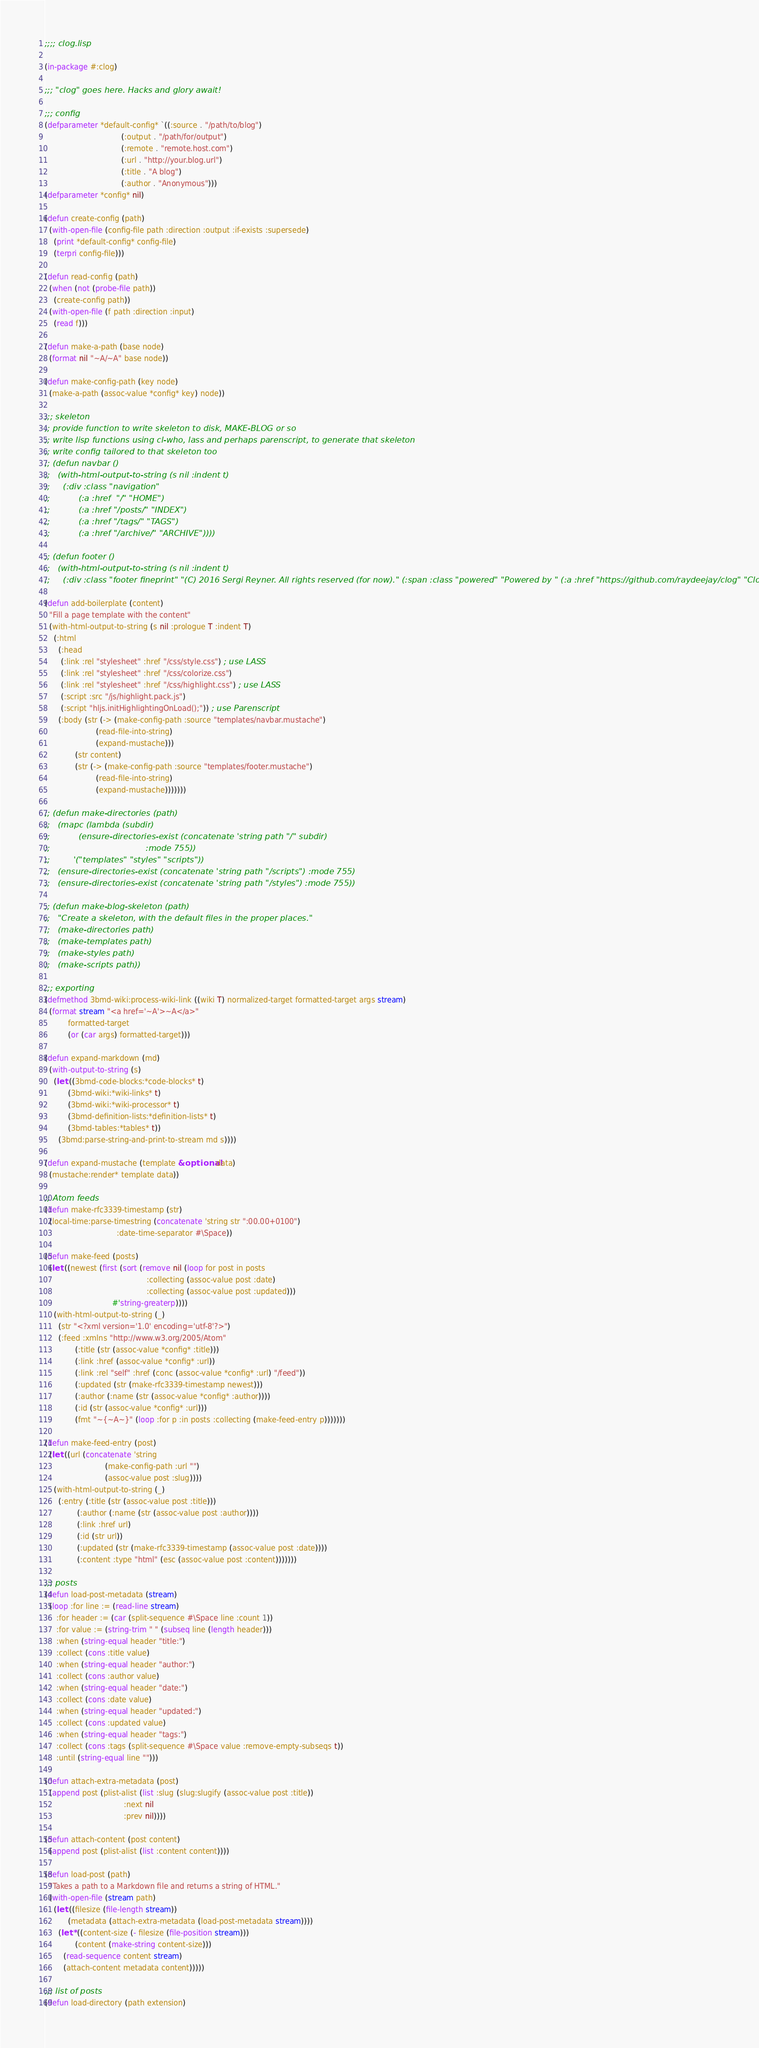Convert code to text. <code><loc_0><loc_0><loc_500><loc_500><_Lisp_>;;;; clog.lisp

(in-package #:clog)

;;; "clog" goes here. Hacks and glory await!

;;; config
(defparameter *default-config* `((:source . "/path/to/blog")
                                 (:output . "/path/for/output")
                                 (:remote . "remote.host.com")
                                 (:url . "http://your.blog.url")
                                 (:title . "A blog")
                                 (:author . "Anonymous")))
(defparameter *config* nil)

(defun create-config (path)
  (with-open-file (config-file path :direction :output :if-exists :supersede)
    (print *default-config* config-file)
    (terpri config-file)))

(defun read-config (path)
  (when (not (probe-file path))
    (create-config path))
  (with-open-file (f path :direction :input)
    (read f)))

(defun make-a-path (base node)
  (format nil "~A/~A" base node))

(defun make-config-path (key node)
  (make-a-path (assoc-value *config* key) node))

;;; skeleton
;; provide function to write skeleton to disk, MAKE-BLOG or so
;; write lisp functions using cl-who, lass and perhaps parenscript, to generate that skeleton
;; write config tailored to that skeleton too
;; (defun navbar ()
;;   (with-html-output-to-string (s nil :indent t)
;;     (:div :class "navigation"
;;           (:a :href  "/" "HOME")
;;           (:a :href "/posts/" "INDEX")
;;           (:a :href "/tags/" "TAGS")
;;           (:a :href "/archive/" "ARCHIVE"))))

;; (defun footer ()
;;   (with-html-output-to-string (s nil :indent t)
;;     (:div :class "footer fineprint" "(C) 2016 Sergi Reyner. All rights reserved (for now)." (:span :class "powered" "Powered by " (:a :href "https://github.com/raydeejay/clog" "Clog") "."))))

(defun add-boilerplate (content)
  "Fill a page template with the content"
  (with-html-output-to-string (s nil :prologue T :indent T)
    (:html
      (:head
       (:link :rel "stylesheet" :href "/css/style.css") ; use LASS
       (:link :rel "stylesheet" :href "/css/colorize.css")
       (:link :rel "stylesheet" :href "/css/highlight.css") ; use LASS
       (:script :src "/js/highlight.pack.js")
       (:script "hljs.initHighlightingOnLoad();")) ; use Parenscript
      (:body (str (-> (make-config-path :source "templates/navbar.mustache")
                      (read-file-into-string)
                      (expand-mustache)))
             (str content)
             (str (-> (make-config-path :source "templates/footer.mustache")
                      (read-file-into-string)
                      (expand-mustache)))))))

;; (defun make-directories (path)
;;   (mapc (lambda (subdir)
;;           (ensure-directories-exist (concatenate 'string path "/" subdir)
;;                                     :mode 755))
;;         '("templates" "styles" "scripts"))
;;   (ensure-directories-exist (concatenate 'string path "/scripts") :mode 755)
;;   (ensure-directories-exist (concatenate 'string path "/styles") :mode 755))

;; (defun make-blog-skeleton (path)
;;   "Create a skeleton, with the default files in the proper places."
;;   (make-directories path)
;;   (make-templates path)
;;   (make-styles path)
;;   (make-scripts path))

;;; exporting
(defmethod 3bmd-wiki:process-wiki-link ((wiki T) normalized-target formatted-target args stream)
  (format stream "<a href='~A'>~A</a>"
          formatted-target
          (or (car args) formatted-target)))

(defun expand-markdown (md)
  (with-output-to-string (s)
    (let ((3bmd-code-blocks:*code-blocks* t)
          (3bmd-wiki:*wiki-links* t)
          (3bmd-wiki:*wiki-processor* t)
          (3bmd-definition-lists:*definition-lists* t)
          (3bmd-tables:*tables* t))
      (3bmd:parse-string-and-print-to-stream md s))))

(defun expand-mustache (template &optional data)
  (mustache:render* template data))

;; Atom feeds
(defun make-rfc3339-timestamp (str)
  (local-time:parse-timestring (concatenate 'string str ":00.00+0100")
                               :date-time-separator #\Space))

(defun make-feed (posts)
  (let ((newest (first (sort (remove nil (loop for post in posts
                                            :collecting (assoc-value post :date)
                                            :collecting (assoc-value post :updated)))
                             #'string-greaterp))))
    (with-html-output-to-string (_)
      (str "<?xml version='1.0' encoding='utf-8'?>")
      (:feed :xmlns "http://www.w3.org/2005/Atom"
             (:title (str (assoc-value *config* :title)))
             (:link :href (assoc-value *config* :url))
             (:link :rel "self" :href (conc (assoc-value *config* :url) "/feed"))
             (:updated (str (make-rfc3339-timestamp newest)))
             (:author (:name (str (assoc-value *config* :author))))
             (:id (str (assoc-value *config* :url)))
             (fmt "~{~A~}" (loop :for p :in posts :collecting (make-feed-entry p)))))))

(defun make-feed-entry (post)
  (let ((url (concatenate 'string
                          (make-config-path :url "")
                          (assoc-value post :slug))))
    (with-html-output-to-string (_)
      (:entry (:title (str (assoc-value post :title)))
              (:author (:name (str (assoc-value post :author))))
              (:link :href url)
              (:id (str url))
              (:updated (str (make-rfc3339-timestamp (assoc-value post :date))))
              (:content :type "html" (esc (assoc-value post :content)))))))

;;; posts
(defun load-post-metadata (stream)
  (loop :for line := (read-line stream)
     :for header := (car (split-sequence #\Space line :count 1))
     :for value := (string-trim " " (subseq line (length header)))
     :when (string-equal header "title:")
     :collect (cons :title value)
     :when (string-equal header "author:")
     :collect (cons :author value)
     :when (string-equal header "date:")
     :collect (cons :date value)
     :when (string-equal header "updated:")
     :collect (cons :updated value)
     :when (string-equal header "tags:")
     :collect (cons :tags (split-sequence #\Space value :remove-empty-subseqs t))
     :until (string-equal line "")))

(defun attach-extra-metadata (post)
  (append post (plist-alist (list :slug (slug:slugify (assoc-value post :title))
                                  :next nil
                                  :prev nil))))

(defun attach-content (post content)
  (append post (plist-alist (list :content content))))

(defun load-post (path)
  "Takes a path to a Markdown file and returns a string of HTML."
  (with-open-file (stream path)
    (let ((filesize (file-length stream))
          (metadata (attach-extra-metadata (load-post-metadata stream))))
      (let* ((content-size (- filesize (file-position stream)))
             (content (make-string content-size)))
        (read-sequence content stream)
        (attach-content metadata content)))))

;;; list of posts
(defun load-directory (path extension)</code> 